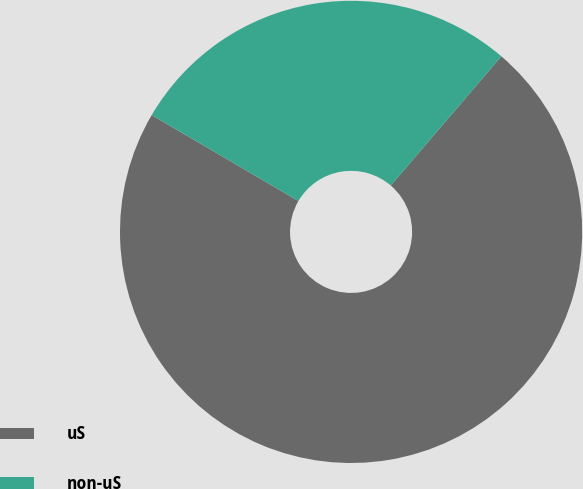Convert chart. <chart><loc_0><loc_0><loc_500><loc_500><pie_chart><fcel>uS<fcel>non-uS<nl><fcel>72.17%<fcel>27.83%<nl></chart> 